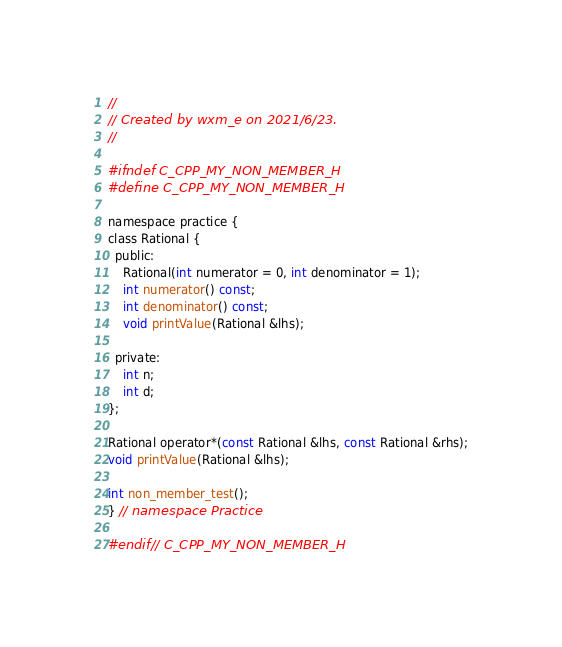<code> <loc_0><loc_0><loc_500><loc_500><_C_>//
// Created by wxm_e on 2021/6/23.
//

#ifndef C_CPP_MY_NON_MEMBER_H
#define C_CPP_MY_NON_MEMBER_H

namespace practice {
class Rational {
  public:
    Rational(int numerator = 0, int denominator = 1);
    int numerator() const;
    int denominator() const;
    void printValue(Rational &lhs);

  private:
    int n;
    int d;
};

Rational operator*(const Rational &lhs, const Rational &rhs);
void printValue(Rational &lhs);

int non_member_test();
} // namespace Practice

#endif // C_CPP_MY_NON_MEMBER_H
</code> 